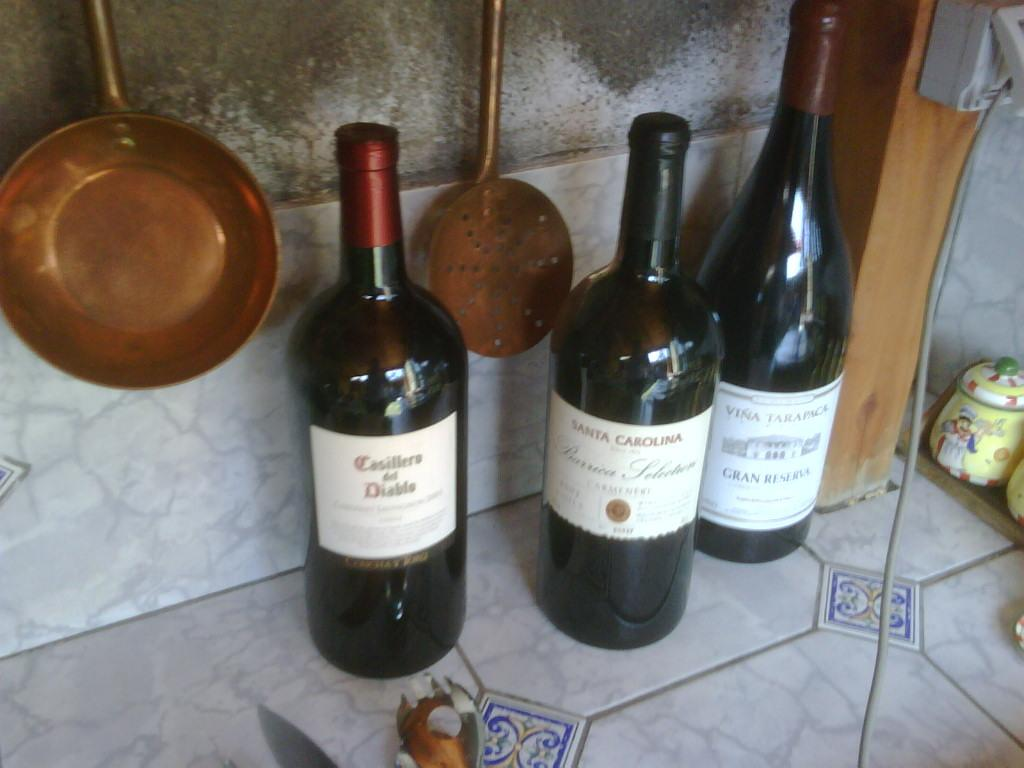<image>
Describe the image concisely. Three bottles of wine including one from Santa Carolina sit on a counter. 